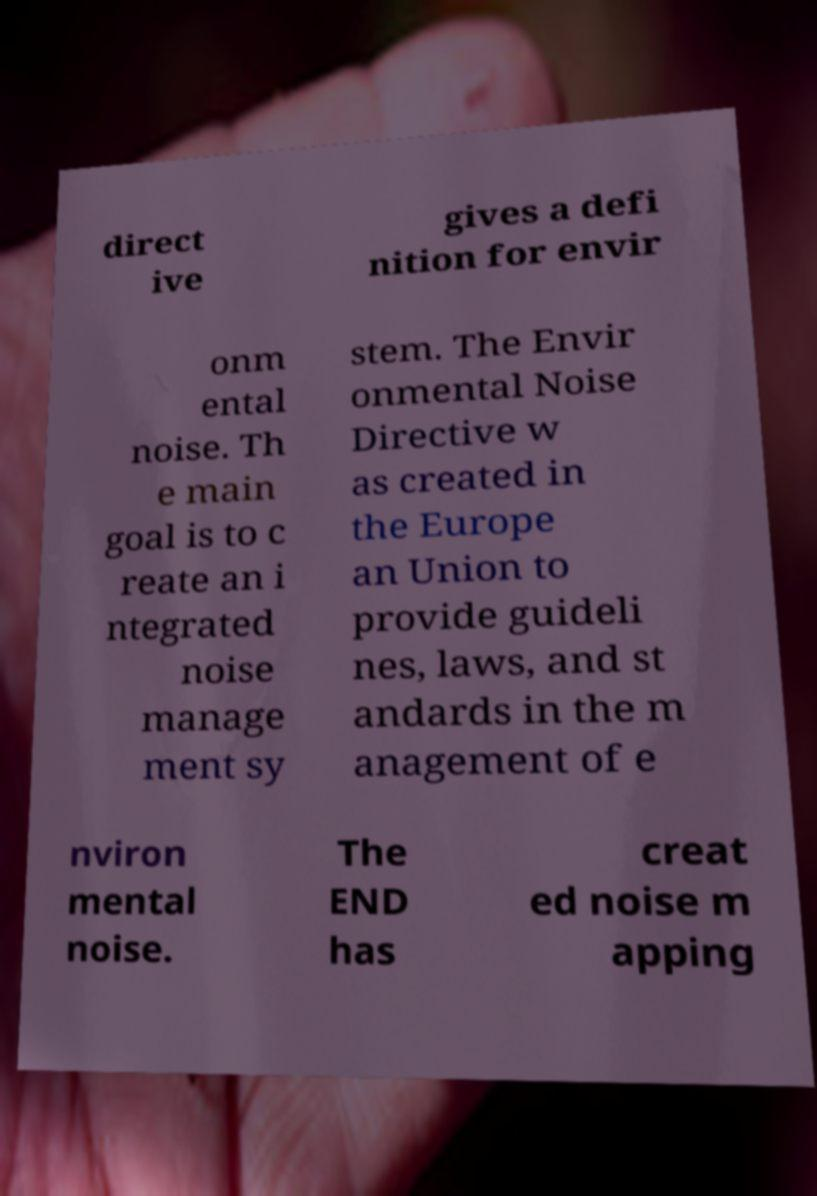Could you assist in decoding the text presented in this image and type it out clearly? direct ive gives a defi nition for envir onm ental noise. Th e main goal is to c reate an i ntegrated noise manage ment sy stem. The Envir onmental Noise Directive w as created in the Europe an Union to provide guideli nes, laws, and st andards in the m anagement of e nviron mental noise. The END has creat ed noise m apping 